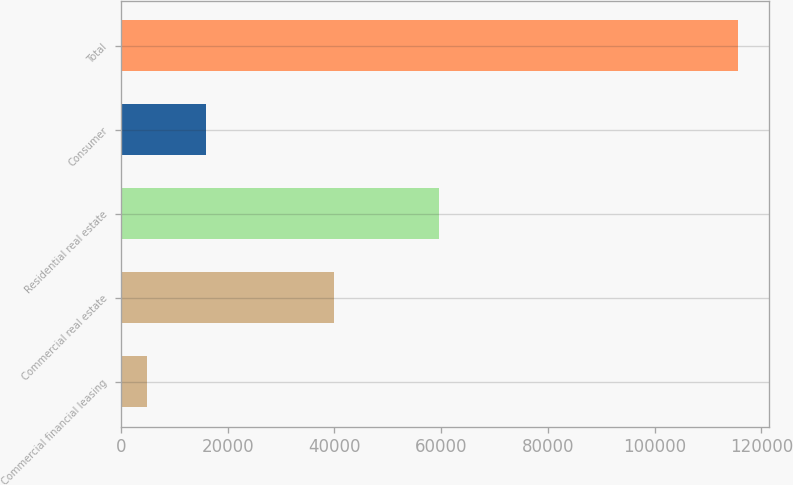Convert chart to OTSL. <chart><loc_0><loc_0><loc_500><loc_500><bar_chart><fcel>Commercial financial leasing<fcel>Commercial real estate<fcel>Residential real estate<fcel>Consumer<fcel>Total<nl><fcel>4794<fcel>39867<fcel>59657<fcel>15873.9<fcel>115593<nl></chart> 